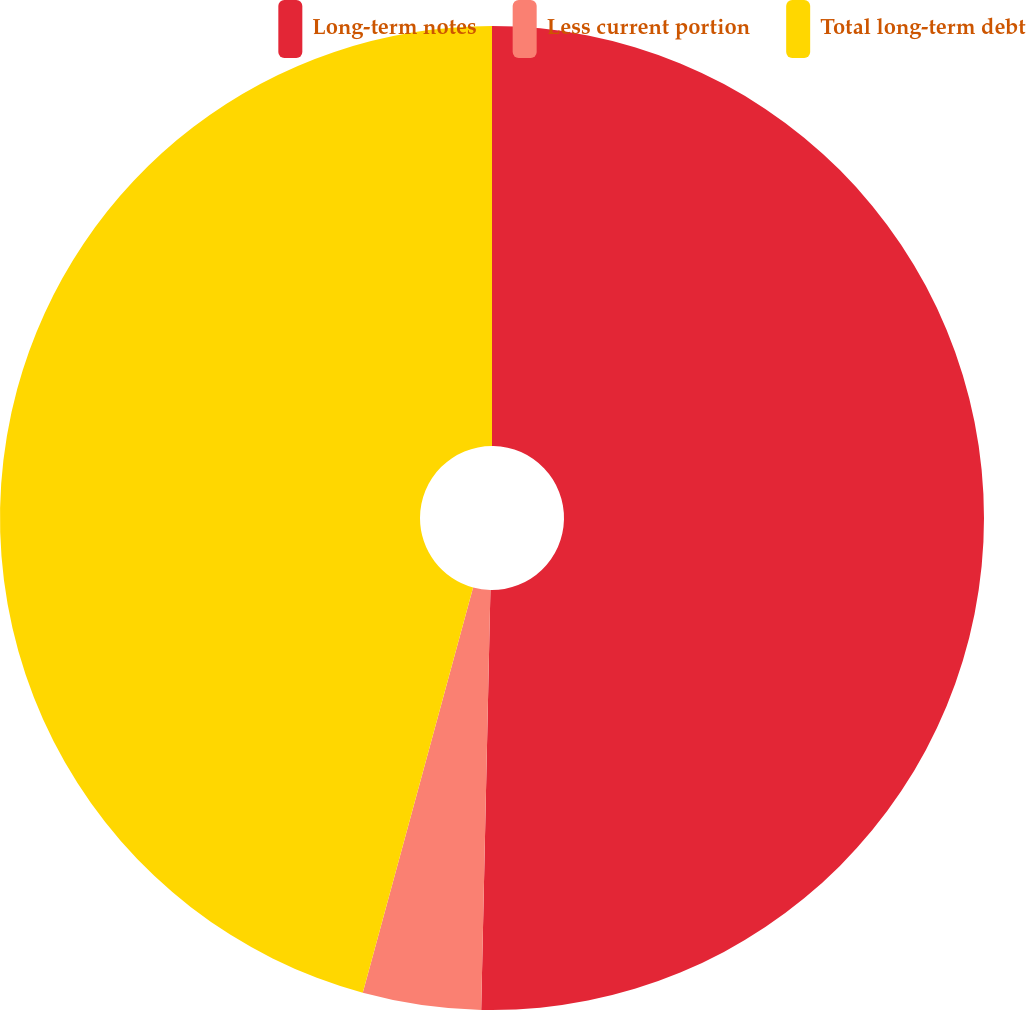Convert chart. <chart><loc_0><loc_0><loc_500><loc_500><pie_chart><fcel>Long-term notes<fcel>Less current portion<fcel>Total long-term debt<nl><fcel>50.35%<fcel>3.88%<fcel>45.77%<nl></chart> 